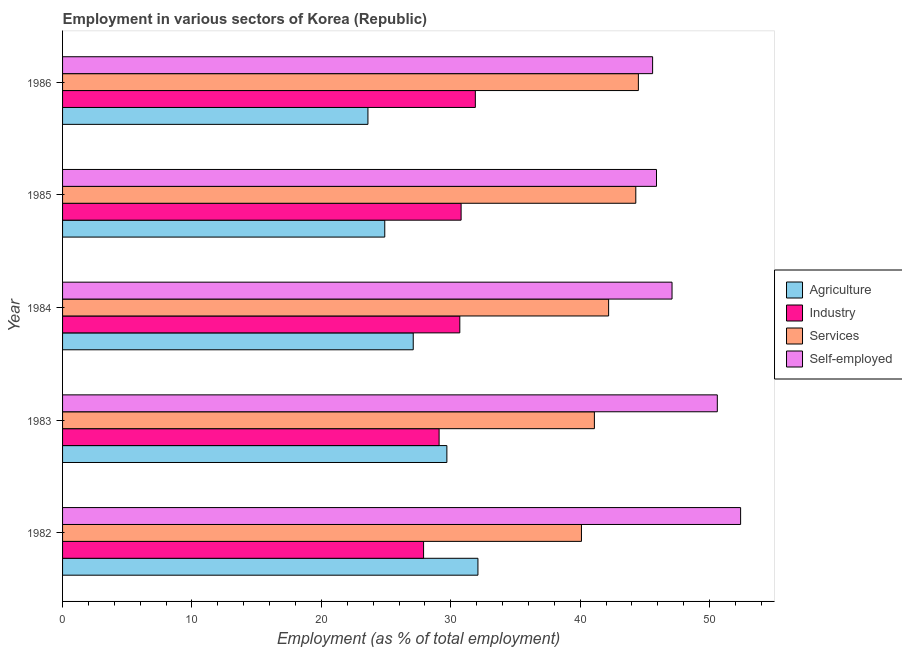How many different coloured bars are there?
Give a very brief answer. 4. What is the label of the 5th group of bars from the top?
Offer a terse response. 1982. In how many cases, is the number of bars for a given year not equal to the number of legend labels?
Provide a short and direct response. 0. What is the percentage of workers in services in 1985?
Offer a terse response. 44.3. Across all years, what is the maximum percentage of workers in services?
Offer a very short reply. 44.5. Across all years, what is the minimum percentage of workers in agriculture?
Offer a very short reply. 23.6. In which year was the percentage of workers in services maximum?
Provide a short and direct response. 1986. In which year was the percentage of workers in services minimum?
Offer a terse response. 1982. What is the total percentage of workers in services in the graph?
Provide a succinct answer. 212.2. What is the difference between the percentage of self employed workers in 1985 and the percentage of workers in industry in 1984?
Your answer should be very brief. 15.2. What is the average percentage of workers in agriculture per year?
Make the answer very short. 27.48. In the year 1982, what is the difference between the percentage of workers in agriculture and percentage of workers in industry?
Offer a very short reply. 4.2. In how many years, is the percentage of workers in agriculture greater than 16 %?
Give a very brief answer. 5. What is the ratio of the percentage of workers in services in 1984 to that in 1985?
Provide a short and direct response. 0.95. Is the difference between the percentage of workers in agriculture in 1984 and 1986 greater than the difference between the percentage of workers in services in 1984 and 1986?
Offer a terse response. Yes. What is the difference between the highest and the second highest percentage of workers in industry?
Provide a succinct answer. 1.1. What is the difference between the highest and the lowest percentage of workers in industry?
Offer a terse response. 4. In how many years, is the percentage of workers in agriculture greater than the average percentage of workers in agriculture taken over all years?
Make the answer very short. 2. Is the sum of the percentage of workers in industry in 1982 and 1984 greater than the maximum percentage of workers in agriculture across all years?
Offer a very short reply. Yes. What does the 3rd bar from the top in 1983 represents?
Provide a succinct answer. Industry. What does the 2nd bar from the bottom in 1986 represents?
Your answer should be very brief. Industry. How many bars are there?
Make the answer very short. 20. Are all the bars in the graph horizontal?
Your answer should be very brief. Yes. How many years are there in the graph?
Keep it short and to the point. 5. What is the difference between two consecutive major ticks on the X-axis?
Ensure brevity in your answer.  10. Are the values on the major ticks of X-axis written in scientific E-notation?
Offer a very short reply. No. Does the graph contain grids?
Offer a very short reply. No. What is the title of the graph?
Offer a very short reply. Employment in various sectors of Korea (Republic). What is the label or title of the X-axis?
Give a very brief answer. Employment (as % of total employment). What is the Employment (as % of total employment) in Agriculture in 1982?
Offer a terse response. 32.1. What is the Employment (as % of total employment) in Industry in 1982?
Make the answer very short. 27.9. What is the Employment (as % of total employment) in Services in 1982?
Give a very brief answer. 40.1. What is the Employment (as % of total employment) of Self-employed in 1982?
Keep it short and to the point. 52.4. What is the Employment (as % of total employment) of Agriculture in 1983?
Keep it short and to the point. 29.7. What is the Employment (as % of total employment) in Industry in 1983?
Provide a short and direct response. 29.1. What is the Employment (as % of total employment) in Services in 1983?
Provide a short and direct response. 41.1. What is the Employment (as % of total employment) in Self-employed in 1983?
Make the answer very short. 50.6. What is the Employment (as % of total employment) in Agriculture in 1984?
Your answer should be compact. 27.1. What is the Employment (as % of total employment) of Industry in 1984?
Give a very brief answer. 30.7. What is the Employment (as % of total employment) in Services in 1984?
Offer a very short reply. 42.2. What is the Employment (as % of total employment) of Self-employed in 1984?
Offer a terse response. 47.1. What is the Employment (as % of total employment) in Agriculture in 1985?
Offer a very short reply. 24.9. What is the Employment (as % of total employment) in Industry in 1985?
Make the answer very short. 30.8. What is the Employment (as % of total employment) of Services in 1985?
Give a very brief answer. 44.3. What is the Employment (as % of total employment) of Self-employed in 1985?
Your answer should be very brief. 45.9. What is the Employment (as % of total employment) in Agriculture in 1986?
Your answer should be very brief. 23.6. What is the Employment (as % of total employment) of Industry in 1986?
Offer a terse response. 31.9. What is the Employment (as % of total employment) of Services in 1986?
Offer a very short reply. 44.5. What is the Employment (as % of total employment) in Self-employed in 1986?
Ensure brevity in your answer.  45.6. Across all years, what is the maximum Employment (as % of total employment) in Agriculture?
Offer a very short reply. 32.1. Across all years, what is the maximum Employment (as % of total employment) of Industry?
Ensure brevity in your answer.  31.9. Across all years, what is the maximum Employment (as % of total employment) in Services?
Provide a short and direct response. 44.5. Across all years, what is the maximum Employment (as % of total employment) of Self-employed?
Your response must be concise. 52.4. Across all years, what is the minimum Employment (as % of total employment) in Agriculture?
Your answer should be compact. 23.6. Across all years, what is the minimum Employment (as % of total employment) of Industry?
Keep it short and to the point. 27.9. Across all years, what is the minimum Employment (as % of total employment) in Services?
Offer a terse response. 40.1. Across all years, what is the minimum Employment (as % of total employment) in Self-employed?
Ensure brevity in your answer.  45.6. What is the total Employment (as % of total employment) in Agriculture in the graph?
Provide a short and direct response. 137.4. What is the total Employment (as % of total employment) in Industry in the graph?
Keep it short and to the point. 150.4. What is the total Employment (as % of total employment) of Services in the graph?
Provide a short and direct response. 212.2. What is the total Employment (as % of total employment) in Self-employed in the graph?
Give a very brief answer. 241.6. What is the difference between the Employment (as % of total employment) of Agriculture in 1982 and that in 1983?
Offer a terse response. 2.4. What is the difference between the Employment (as % of total employment) in Self-employed in 1982 and that in 1983?
Provide a succinct answer. 1.8. What is the difference between the Employment (as % of total employment) of Services in 1982 and that in 1984?
Your answer should be very brief. -2.1. What is the difference between the Employment (as % of total employment) of Agriculture in 1982 and that in 1985?
Make the answer very short. 7.2. What is the difference between the Employment (as % of total employment) of Industry in 1982 and that in 1985?
Keep it short and to the point. -2.9. What is the difference between the Employment (as % of total employment) in Self-employed in 1982 and that in 1985?
Give a very brief answer. 6.5. What is the difference between the Employment (as % of total employment) of Agriculture in 1982 and that in 1986?
Provide a succinct answer. 8.5. What is the difference between the Employment (as % of total employment) of Industry in 1982 and that in 1986?
Offer a terse response. -4. What is the difference between the Employment (as % of total employment) of Services in 1982 and that in 1986?
Make the answer very short. -4.4. What is the difference between the Employment (as % of total employment) of Self-employed in 1982 and that in 1986?
Ensure brevity in your answer.  6.8. What is the difference between the Employment (as % of total employment) of Agriculture in 1983 and that in 1984?
Provide a succinct answer. 2.6. What is the difference between the Employment (as % of total employment) in Services in 1983 and that in 1984?
Provide a succinct answer. -1.1. What is the difference between the Employment (as % of total employment) in Self-employed in 1983 and that in 1984?
Give a very brief answer. 3.5. What is the difference between the Employment (as % of total employment) of Industry in 1983 and that in 1985?
Provide a succinct answer. -1.7. What is the difference between the Employment (as % of total employment) of Services in 1983 and that in 1985?
Your answer should be compact. -3.2. What is the difference between the Employment (as % of total employment) in Self-employed in 1983 and that in 1985?
Ensure brevity in your answer.  4.7. What is the difference between the Employment (as % of total employment) of Agriculture in 1983 and that in 1986?
Provide a short and direct response. 6.1. What is the difference between the Employment (as % of total employment) in Industry in 1983 and that in 1986?
Your response must be concise. -2.8. What is the difference between the Employment (as % of total employment) in Self-employed in 1983 and that in 1986?
Provide a short and direct response. 5. What is the difference between the Employment (as % of total employment) in Services in 1984 and that in 1985?
Provide a succinct answer. -2.1. What is the difference between the Employment (as % of total employment) in Self-employed in 1984 and that in 1985?
Provide a short and direct response. 1.2. What is the difference between the Employment (as % of total employment) of Services in 1984 and that in 1986?
Your response must be concise. -2.3. What is the difference between the Employment (as % of total employment) in Self-employed in 1984 and that in 1986?
Make the answer very short. 1.5. What is the difference between the Employment (as % of total employment) of Agriculture in 1985 and that in 1986?
Make the answer very short. 1.3. What is the difference between the Employment (as % of total employment) in Services in 1985 and that in 1986?
Your response must be concise. -0.2. What is the difference between the Employment (as % of total employment) in Agriculture in 1982 and the Employment (as % of total employment) in Services in 1983?
Give a very brief answer. -9. What is the difference between the Employment (as % of total employment) in Agriculture in 1982 and the Employment (as % of total employment) in Self-employed in 1983?
Make the answer very short. -18.5. What is the difference between the Employment (as % of total employment) in Industry in 1982 and the Employment (as % of total employment) in Self-employed in 1983?
Your answer should be very brief. -22.7. What is the difference between the Employment (as % of total employment) in Agriculture in 1982 and the Employment (as % of total employment) in Services in 1984?
Your answer should be compact. -10.1. What is the difference between the Employment (as % of total employment) of Industry in 1982 and the Employment (as % of total employment) of Services in 1984?
Your answer should be compact. -14.3. What is the difference between the Employment (as % of total employment) of Industry in 1982 and the Employment (as % of total employment) of Self-employed in 1984?
Offer a very short reply. -19.2. What is the difference between the Employment (as % of total employment) in Services in 1982 and the Employment (as % of total employment) in Self-employed in 1984?
Ensure brevity in your answer.  -7. What is the difference between the Employment (as % of total employment) of Agriculture in 1982 and the Employment (as % of total employment) of Industry in 1985?
Your answer should be very brief. 1.3. What is the difference between the Employment (as % of total employment) of Agriculture in 1982 and the Employment (as % of total employment) of Self-employed in 1985?
Your answer should be compact. -13.8. What is the difference between the Employment (as % of total employment) in Industry in 1982 and the Employment (as % of total employment) in Services in 1985?
Your response must be concise. -16.4. What is the difference between the Employment (as % of total employment) in Agriculture in 1982 and the Employment (as % of total employment) in Services in 1986?
Your answer should be compact. -12.4. What is the difference between the Employment (as % of total employment) in Agriculture in 1982 and the Employment (as % of total employment) in Self-employed in 1986?
Your answer should be very brief. -13.5. What is the difference between the Employment (as % of total employment) in Industry in 1982 and the Employment (as % of total employment) in Services in 1986?
Offer a very short reply. -16.6. What is the difference between the Employment (as % of total employment) of Industry in 1982 and the Employment (as % of total employment) of Self-employed in 1986?
Keep it short and to the point. -17.7. What is the difference between the Employment (as % of total employment) in Agriculture in 1983 and the Employment (as % of total employment) in Industry in 1984?
Your answer should be very brief. -1. What is the difference between the Employment (as % of total employment) of Agriculture in 1983 and the Employment (as % of total employment) of Self-employed in 1984?
Your answer should be compact. -17.4. What is the difference between the Employment (as % of total employment) of Industry in 1983 and the Employment (as % of total employment) of Services in 1984?
Offer a very short reply. -13.1. What is the difference between the Employment (as % of total employment) of Agriculture in 1983 and the Employment (as % of total employment) of Industry in 1985?
Offer a very short reply. -1.1. What is the difference between the Employment (as % of total employment) in Agriculture in 1983 and the Employment (as % of total employment) in Services in 1985?
Give a very brief answer. -14.6. What is the difference between the Employment (as % of total employment) of Agriculture in 1983 and the Employment (as % of total employment) of Self-employed in 1985?
Your answer should be very brief. -16.2. What is the difference between the Employment (as % of total employment) in Industry in 1983 and the Employment (as % of total employment) in Services in 1985?
Your answer should be compact. -15.2. What is the difference between the Employment (as % of total employment) in Industry in 1983 and the Employment (as % of total employment) in Self-employed in 1985?
Your answer should be very brief. -16.8. What is the difference between the Employment (as % of total employment) in Services in 1983 and the Employment (as % of total employment) in Self-employed in 1985?
Your answer should be compact. -4.8. What is the difference between the Employment (as % of total employment) of Agriculture in 1983 and the Employment (as % of total employment) of Services in 1986?
Provide a succinct answer. -14.8. What is the difference between the Employment (as % of total employment) in Agriculture in 1983 and the Employment (as % of total employment) in Self-employed in 1986?
Provide a short and direct response. -15.9. What is the difference between the Employment (as % of total employment) in Industry in 1983 and the Employment (as % of total employment) in Services in 1986?
Offer a very short reply. -15.4. What is the difference between the Employment (as % of total employment) in Industry in 1983 and the Employment (as % of total employment) in Self-employed in 1986?
Offer a very short reply. -16.5. What is the difference between the Employment (as % of total employment) in Agriculture in 1984 and the Employment (as % of total employment) in Services in 1985?
Your response must be concise. -17.2. What is the difference between the Employment (as % of total employment) of Agriculture in 1984 and the Employment (as % of total employment) of Self-employed in 1985?
Your answer should be very brief. -18.8. What is the difference between the Employment (as % of total employment) of Industry in 1984 and the Employment (as % of total employment) of Self-employed in 1985?
Your response must be concise. -15.2. What is the difference between the Employment (as % of total employment) of Services in 1984 and the Employment (as % of total employment) of Self-employed in 1985?
Offer a very short reply. -3.7. What is the difference between the Employment (as % of total employment) of Agriculture in 1984 and the Employment (as % of total employment) of Services in 1986?
Ensure brevity in your answer.  -17.4. What is the difference between the Employment (as % of total employment) of Agriculture in 1984 and the Employment (as % of total employment) of Self-employed in 1986?
Offer a terse response. -18.5. What is the difference between the Employment (as % of total employment) in Industry in 1984 and the Employment (as % of total employment) in Self-employed in 1986?
Your answer should be compact. -14.9. What is the difference between the Employment (as % of total employment) in Agriculture in 1985 and the Employment (as % of total employment) in Services in 1986?
Keep it short and to the point. -19.6. What is the difference between the Employment (as % of total employment) of Agriculture in 1985 and the Employment (as % of total employment) of Self-employed in 1986?
Your response must be concise. -20.7. What is the difference between the Employment (as % of total employment) of Industry in 1985 and the Employment (as % of total employment) of Services in 1986?
Make the answer very short. -13.7. What is the difference between the Employment (as % of total employment) in Industry in 1985 and the Employment (as % of total employment) in Self-employed in 1986?
Provide a short and direct response. -14.8. What is the difference between the Employment (as % of total employment) of Services in 1985 and the Employment (as % of total employment) of Self-employed in 1986?
Your answer should be very brief. -1.3. What is the average Employment (as % of total employment) of Agriculture per year?
Provide a short and direct response. 27.48. What is the average Employment (as % of total employment) of Industry per year?
Give a very brief answer. 30.08. What is the average Employment (as % of total employment) of Services per year?
Keep it short and to the point. 42.44. What is the average Employment (as % of total employment) in Self-employed per year?
Your response must be concise. 48.32. In the year 1982, what is the difference between the Employment (as % of total employment) in Agriculture and Employment (as % of total employment) in Industry?
Give a very brief answer. 4.2. In the year 1982, what is the difference between the Employment (as % of total employment) of Agriculture and Employment (as % of total employment) of Services?
Your response must be concise. -8. In the year 1982, what is the difference between the Employment (as % of total employment) of Agriculture and Employment (as % of total employment) of Self-employed?
Your answer should be compact. -20.3. In the year 1982, what is the difference between the Employment (as % of total employment) of Industry and Employment (as % of total employment) of Services?
Keep it short and to the point. -12.2. In the year 1982, what is the difference between the Employment (as % of total employment) in Industry and Employment (as % of total employment) in Self-employed?
Keep it short and to the point. -24.5. In the year 1982, what is the difference between the Employment (as % of total employment) in Services and Employment (as % of total employment) in Self-employed?
Ensure brevity in your answer.  -12.3. In the year 1983, what is the difference between the Employment (as % of total employment) in Agriculture and Employment (as % of total employment) in Industry?
Your answer should be compact. 0.6. In the year 1983, what is the difference between the Employment (as % of total employment) of Agriculture and Employment (as % of total employment) of Services?
Your answer should be compact. -11.4. In the year 1983, what is the difference between the Employment (as % of total employment) in Agriculture and Employment (as % of total employment) in Self-employed?
Your answer should be very brief. -20.9. In the year 1983, what is the difference between the Employment (as % of total employment) of Industry and Employment (as % of total employment) of Self-employed?
Your answer should be very brief. -21.5. In the year 1983, what is the difference between the Employment (as % of total employment) of Services and Employment (as % of total employment) of Self-employed?
Your answer should be compact. -9.5. In the year 1984, what is the difference between the Employment (as % of total employment) in Agriculture and Employment (as % of total employment) in Industry?
Offer a terse response. -3.6. In the year 1984, what is the difference between the Employment (as % of total employment) of Agriculture and Employment (as % of total employment) of Services?
Offer a very short reply. -15.1. In the year 1984, what is the difference between the Employment (as % of total employment) of Agriculture and Employment (as % of total employment) of Self-employed?
Provide a short and direct response. -20. In the year 1984, what is the difference between the Employment (as % of total employment) of Industry and Employment (as % of total employment) of Self-employed?
Provide a succinct answer. -16.4. In the year 1984, what is the difference between the Employment (as % of total employment) in Services and Employment (as % of total employment) in Self-employed?
Provide a succinct answer. -4.9. In the year 1985, what is the difference between the Employment (as % of total employment) in Agriculture and Employment (as % of total employment) in Services?
Make the answer very short. -19.4. In the year 1985, what is the difference between the Employment (as % of total employment) in Agriculture and Employment (as % of total employment) in Self-employed?
Provide a succinct answer. -21. In the year 1985, what is the difference between the Employment (as % of total employment) of Industry and Employment (as % of total employment) of Services?
Offer a terse response. -13.5. In the year 1985, what is the difference between the Employment (as % of total employment) in Industry and Employment (as % of total employment) in Self-employed?
Offer a terse response. -15.1. In the year 1986, what is the difference between the Employment (as % of total employment) of Agriculture and Employment (as % of total employment) of Industry?
Your answer should be very brief. -8.3. In the year 1986, what is the difference between the Employment (as % of total employment) of Agriculture and Employment (as % of total employment) of Services?
Make the answer very short. -20.9. In the year 1986, what is the difference between the Employment (as % of total employment) in Industry and Employment (as % of total employment) in Self-employed?
Give a very brief answer. -13.7. What is the ratio of the Employment (as % of total employment) of Agriculture in 1982 to that in 1983?
Give a very brief answer. 1.08. What is the ratio of the Employment (as % of total employment) of Industry in 1982 to that in 1983?
Give a very brief answer. 0.96. What is the ratio of the Employment (as % of total employment) of Services in 1982 to that in 1983?
Ensure brevity in your answer.  0.98. What is the ratio of the Employment (as % of total employment) in Self-employed in 1982 to that in 1983?
Provide a short and direct response. 1.04. What is the ratio of the Employment (as % of total employment) of Agriculture in 1982 to that in 1984?
Make the answer very short. 1.18. What is the ratio of the Employment (as % of total employment) in Industry in 1982 to that in 1984?
Give a very brief answer. 0.91. What is the ratio of the Employment (as % of total employment) of Services in 1982 to that in 1984?
Provide a succinct answer. 0.95. What is the ratio of the Employment (as % of total employment) of Self-employed in 1982 to that in 1984?
Your answer should be compact. 1.11. What is the ratio of the Employment (as % of total employment) in Agriculture in 1982 to that in 1985?
Make the answer very short. 1.29. What is the ratio of the Employment (as % of total employment) of Industry in 1982 to that in 1985?
Your answer should be very brief. 0.91. What is the ratio of the Employment (as % of total employment) in Services in 1982 to that in 1985?
Provide a short and direct response. 0.91. What is the ratio of the Employment (as % of total employment) in Self-employed in 1982 to that in 1985?
Provide a succinct answer. 1.14. What is the ratio of the Employment (as % of total employment) of Agriculture in 1982 to that in 1986?
Your answer should be very brief. 1.36. What is the ratio of the Employment (as % of total employment) of Industry in 1982 to that in 1986?
Offer a terse response. 0.87. What is the ratio of the Employment (as % of total employment) in Services in 1982 to that in 1986?
Provide a succinct answer. 0.9. What is the ratio of the Employment (as % of total employment) in Self-employed in 1982 to that in 1986?
Keep it short and to the point. 1.15. What is the ratio of the Employment (as % of total employment) of Agriculture in 1983 to that in 1984?
Make the answer very short. 1.1. What is the ratio of the Employment (as % of total employment) of Industry in 1983 to that in 1984?
Your response must be concise. 0.95. What is the ratio of the Employment (as % of total employment) of Services in 1983 to that in 1984?
Give a very brief answer. 0.97. What is the ratio of the Employment (as % of total employment) of Self-employed in 1983 to that in 1984?
Offer a terse response. 1.07. What is the ratio of the Employment (as % of total employment) in Agriculture in 1983 to that in 1985?
Ensure brevity in your answer.  1.19. What is the ratio of the Employment (as % of total employment) in Industry in 1983 to that in 1985?
Give a very brief answer. 0.94. What is the ratio of the Employment (as % of total employment) of Services in 1983 to that in 1985?
Give a very brief answer. 0.93. What is the ratio of the Employment (as % of total employment) of Self-employed in 1983 to that in 1985?
Keep it short and to the point. 1.1. What is the ratio of the Employment (as % of total employment) in Agriculture in 1983 to that in 1986?
Your response must be concise. 1.26. What is the ratio of the Employment (as % of total employment) of Industry in 1983 to that in 1986?
Provide a succinct answer. 0.91. What is the ratio of the Employment (as % of total employment) of Services in 1983 to that in 1986?
Offer a very short reply. 0.92. What is the ratio of the Employment (as % of total employment) of Self-employed in 1983 to that in 1986?
Your response must be concise. 1.11. What is the ratio of the Employment (as % of total employment) in Agriculture in 1984 to that in 1985?
Offer a terse response. 1.09. What is the ratio of the Employment (as % of total employment) of Services in 1984 to that in 1985?
Ensure brevity in your answer.  0.95. What is the ratio of the Employment (as % of total employment) in Self-employed in 1984 to that in 1985?
Offer a terse response. 1.03. What is the ratio of the Employment (as % of total employment) in Agriculture in 1984 to that in 1986?
Give a very brief answer. 1.15. What is the ratio of the Employment (as % of total employment) in Industry in 1984 to that in 1986?
Your answer should be very brief. 0.96. What is the ratio of the Employment (as % of total employment) in Services in 1984 to that in 1986?
Give a very brief answer. 0.95. What is the ratio of the Employment (as % of total employment) of Self-employed in 1984 to that in 1986?
Give a very brief answer. 1.03. What is the ratio of the Employment (as % of total employment) of Agriculture in 1985 to that in 1986?
Ensure brevity in your answer.  1.06. What is the ratio of the Employment (as % of total employment) of Industry in 1985 to that in 1986?
Your answer should be very brief. 0.97. What is the ratio of the Employment (as % of total employment) of Self-employed in 1985 to that in 1986?
Make the answer very short. 1.01. What is the difference between the highest and the second highest Employment (as % of total employment) of Services?
Your response must be concise. 0.2. What is the difference between the highest and the second highest Employment (as % of total employment) of Self-employed?
Offer a terse response. 1.8. What is the difference between the highest and the lowest Employment (as % of total employment) in Self-employed?
Give a very brief answer. 6.8. 